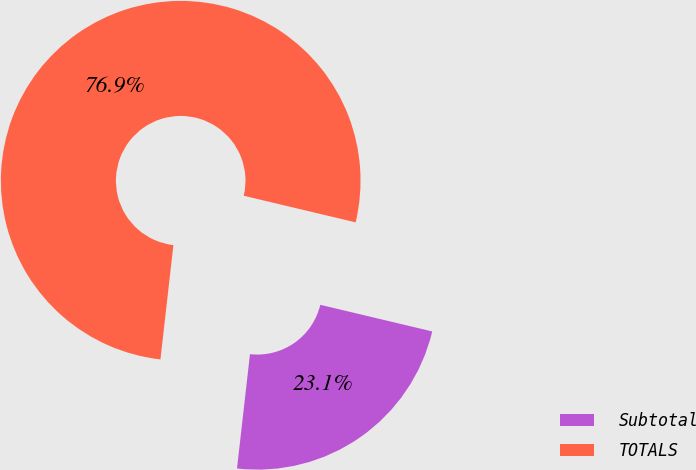Convert chart. <chart><loc_0><loc_0><loc_500><loc_500><pie_chart><fcel>Subtotal<fcel>TOTALS<nl><fcel>23.08%<fcel>76.92%<nl></chart> 